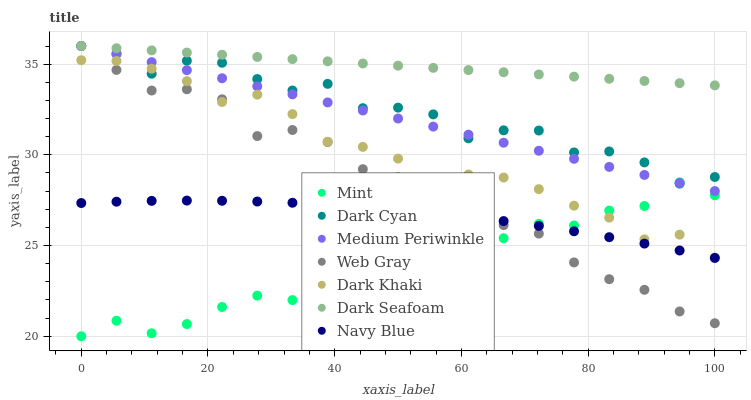Does Mint have the minimum area under the curve?
Answer yes or no. Yes. Does Dark Seafoam have the maximum area under the curve?
Answer yes or no. Yes. Does Navy Blue have the minimum area under the curve?
Answer yes or no. No. Does Navy Blue have the maximum area under the curve?
Answer yes or no. No. Is Dark Seafoam the smoothest?
Answer yes or no. Yes. Is Dark Cyan the roughest?
Answer yes or no. Yes. Is Navy Blue the smoothest?
Answer yes or no. No. Is Navy Blue the roughest?
Answer yes or no. No. Does Mint have the lowest value?
Answer yes or no. Yes. Does Navy Blue have the lowest value?
Answer yes or no. No. Does Dark Cyan have the highest value?
Answer yes or no. Yes. Does Navy Blue have the highest value?
Answer yes or no. No. Is Navy Blue less than Dark Cyan?
Answer yes or no. Yes. Is Medium Periwinkle greater than Dark Khaki?
Answer yes or no. Yes. Does Medium Periwinkle intersect Mint?
Answer yes or no. Yes. Is Medium Periwinkle less than Mint?
Answer yes or no. No. Is Medium Periwinkle greater than Mint?
Answer yes or no. No. Does Navy Blue intersect Dark Cyan?
Answer yes or no. No. 